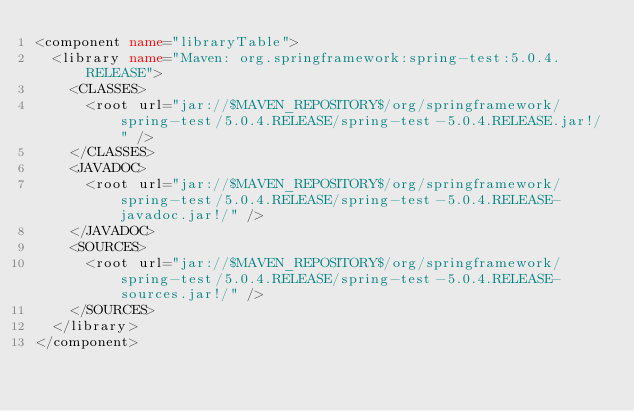Convert code to text. <code><loc_0><loc_0><loc_500><loc_500><_XML_><component name="libraryTable">
  <library name="Maven: org.springframework:spring-test:5.0.4.RELEASE">
    <CLASSES>
      <root url="jar://$MAVEN_REPOSITORY$/org/springframework/spring-test/5.0.4.RELEASE/spring-test-5.0.4.RELEASE.jar!/" />
    </CLASSES>
    <JAVADOC>
      <root url="jar://$MAVEN_REPOSITORY$/org/springframework/spring-test/5.0.4.RELEASE/spring-test-5.0.4.RELEASE-javadoc.jar!/" />
    </JAVADOC>
    <SOURCES>
      <root url="jar://$MAVEN_REPOSITORY$/org/springframework/spring-test/5.0.4.RELEASE/spring-test-5.0.4.RELEASE-sources.jar!/" />
    </SOURCES>
  </library>
</component></code> 